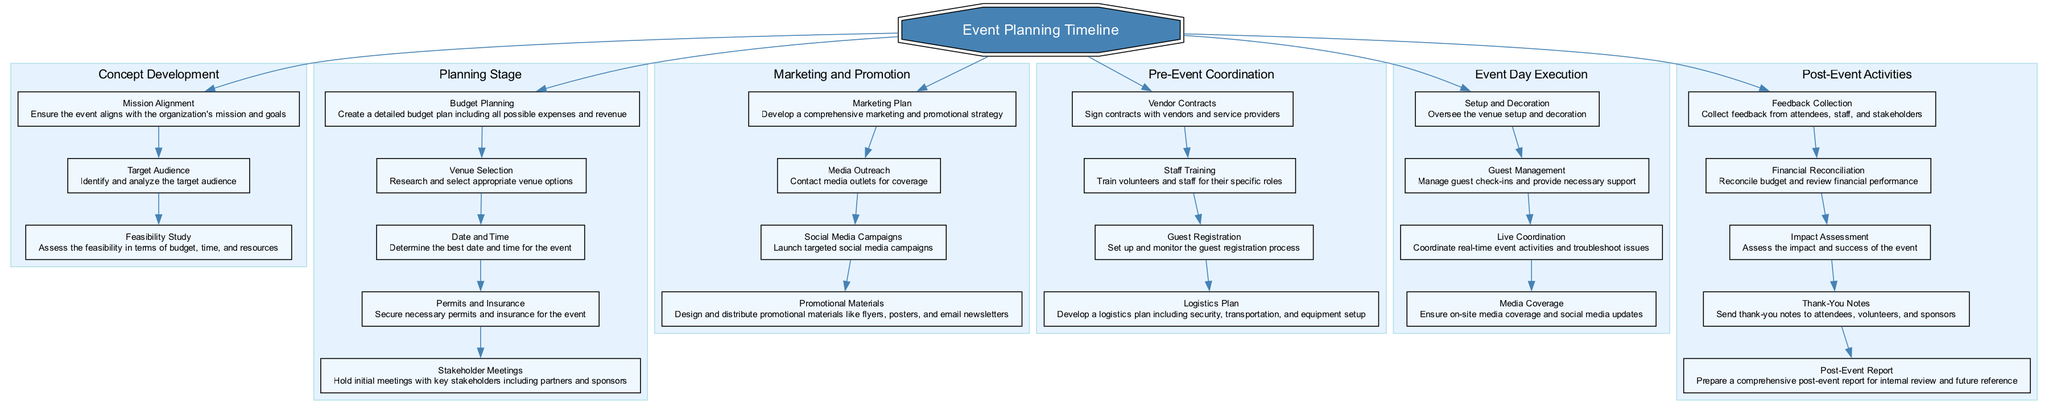What are the stages of the event planning timeline? The diagram includes five main stages: Concept Development, Planning Stage, Marketing and Promotion, Pre-Event Coordination, Event Day Execution, and Post-Event Activities.
Answer: Concept Development, Planning Stage, Marketing and Promotion, Pre-Event Coordination, Event Day Execution, Post-Event Activities How many tasks are listed under Marketing and Promotion? The Marketing and Promotion stage contains four distinct tasks: Marketing Plan, Media Outreach, Social Media Campaigns, and Promotional Materials.
Answer: 4 What is the primary goal of the Concept Development stage? Within the Concept Development stage, the primary focus is on ensuring that the event aligns with the organization's mission and goals, which is stated in the 'Mission Alignment' task.
Answer: Ensure alignment with mission How does the Vendor Contracts task relate to Staff Training? Vendor Contracts is located in the Pre-Event Coordination stage, and it is a prerequisite for Staff Training since contracts with vendors need to be finalized before staff can be trained on their specific roles related to these vendors.
Answer: Vendor Contracts precedes Staff Training Which activities follow the Guest Management task on Event Day Execution? According to the diagram, the task that follows Guest Management in Event Day Execution is Live Coordination, which focuses on coordinating real-time activities during the event.
Answer: Live Coordination What is the final task listed in the Post-Event Activities stage? The final task listed under Post-Event Activities is preparing a comprehensive post-event report for internal review and future reference, ensuring all aspects of the event are documented.
Answer: Post-Event Report How does the Planning Stage relate to the Concept Development stage? The Planning Stage directly follows the Concept Development stage, indicating that the planning activities are contingent on the concepts developed in the prior stage, emphasizing their sequential relationship in the timeline.
Answer: Planning follows Concept Development What task in the Pre-Event Coordination is specifically concerned with security? Within the Pre-Event Coordination stage, the Logistics Plan is the task that specifically addresses security needs, along with transportation and equipment setup.
Answer: Logistics Plan 